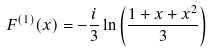<formula> <loc_0><loc_0><loc_500><loc_500>F ^ { ( 1 ) } ( x ) = - \frac { i } { 3 } \ln \left ( \frac { 1 + x + x ^ { 2 } } { 3 } \right )</formula> 